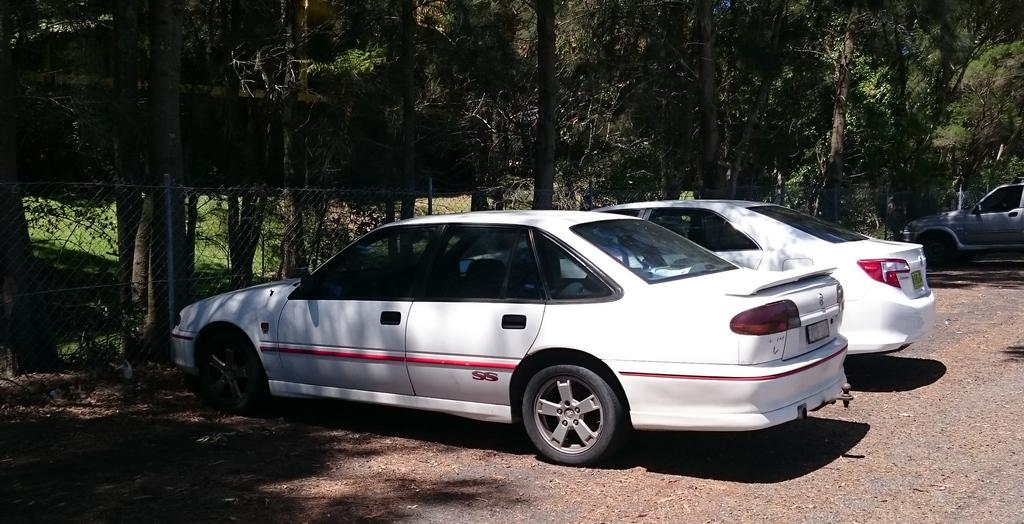What type of vehicles can be seen on the road in the image? There are cars on the road in the image. What can be seen in the distance behind the cars? There are trees visible in the background of the image. Can you describe any specific feature of the image? Yes, there is a mesh present in the image. What type of treatment is being administered to the bomb in the image? There is no bomb present in the image, so no treatment is being administered. 